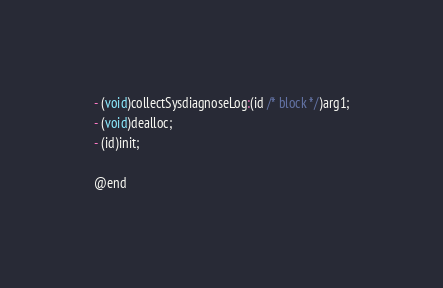<code> <loc_0><loc_0><loc_500><loc_500><_C_>
- (void)collectSysdiagnoseLog:(id /* block */)arg1;
- (void)dealloc;
- (id)init;

@end
</code> 